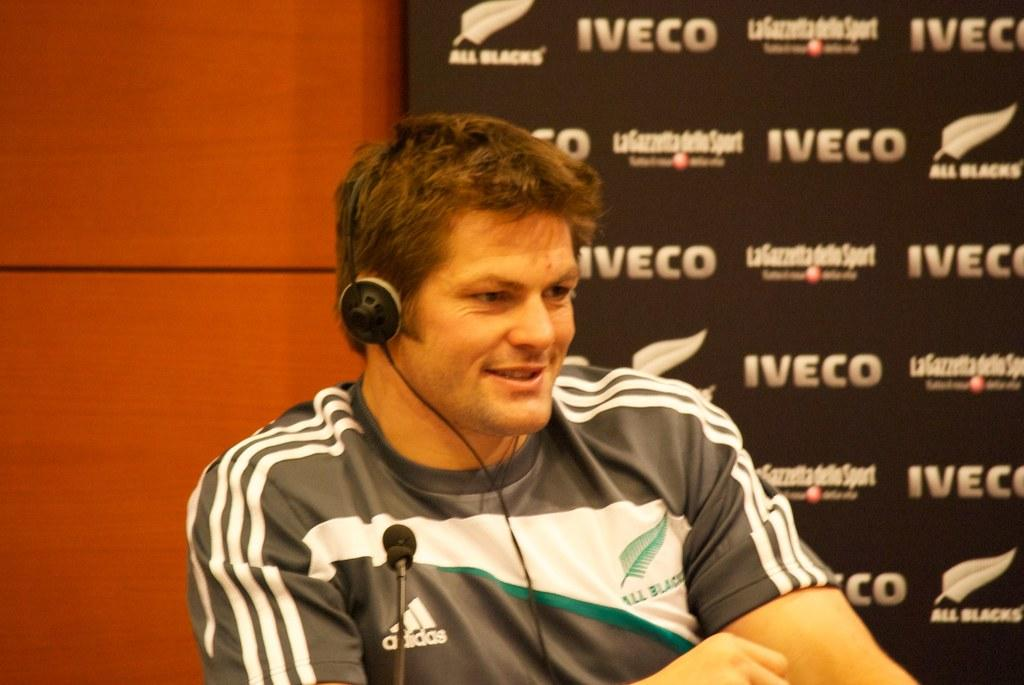<image>
Offer a succinct explanation of the picture presented. A man is wearing some headphones and sitting in front of a Iveco sign. 